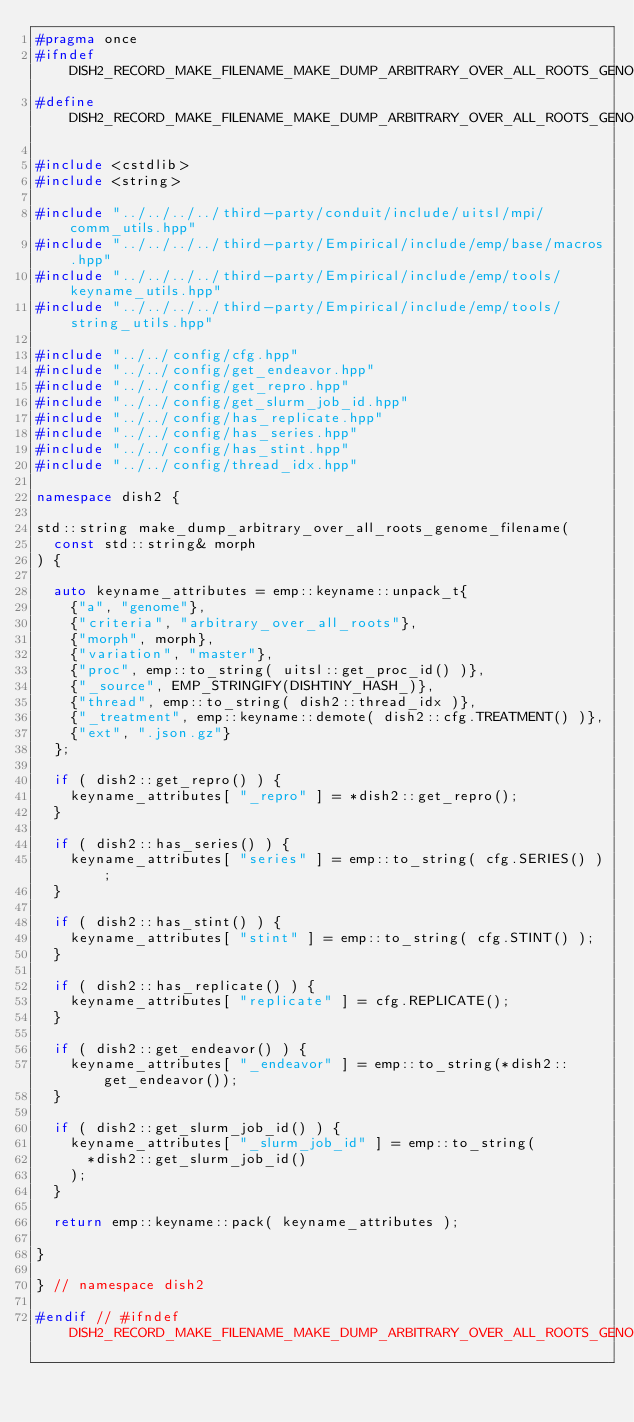<code> <loc_0><loc_0><loc_500><loc_500><_C++_>#pragma once
#ifndef DISH2_RECORD_MAKE_FILENAME_MAKE_DUMP_ARBITRARY_OVER_ALL_ROOTS_GENOME_FILENAME_HPP_INCLUDE
#define DISH2_RECORD_MAKE_FILENAME_MAKE_DUMP_ARBITRARY_OVER_ALL_ROOTS_GENOME_FILENAME_HPP_INCLUDE

#include <cstdlib>
#include <string>

#include "../../../../third-party/conduit/include/uitsl/mpi/comm_utils.hpp"
#include "../../../../third-party/Empirical/include/emp/base/macros.hpp"
#include "../../../../third-party/Empirical/include/emp/tools/keyname_utils.hpp"
#include "../../../../third-party/Empirical/include/emp/tools/string_utils.hpp"

#include "../../config/cfg.hpp"
#include "../../config/get_endeavor.hpp"
#include "../../config/get_repro.hpp"
#include "../../config/get_slurm_job_id.hpp"
#include "../../config/has_replicate.hpp"
#include "../../config/has_series.hpp"
#include "../../config/has_stint.hpp"
#include "../../config/thread_idx.hpp"

namespace dish2 {

std::string make_dump_arbitrary_over_all_roots_genome_filename(
  const std::string& morph
) {

  auto keyname_attributes = emp::keyname::unpack_t{
    {"a", "genome"},
    {"criteria", "arbitrary_over_all_roots"},
    {"morph", morph},
    {"variation", "master"},
    {"proc", emp::to_string( uitsl::get_proc_id() )},
    {"_source", EMP_STRINGIFY(DISHTINY_HASH_)},
    {"thread", emp::to_string( dish2::thread_idx )},
    {"_treatment", emp::keyname::demote( dish2::cfg.TREATMENT() )},
    {"ext", ".json.gz"}
  };

  if ( dish2::get_repro() ) {
    keyname_attributes[ "_repro" ] = *dish2::get_repro();
  }

  if ( dish2::has_series() ) {
    keyname_attributes[ "series" ] = emp::to_string( cfg.SERIES() );
  }

  if ( dish2::has_stint() ) {
    keyname_attributes[ "stint" ] = emp::to_string( cfg.STINT() );
  }

  if ( dish2::has_replicate() ) {
    keyname_attributes[ "replicate" ] = cfg.REPLICATE();
  }

  if ( dish2::get_endeavor() ) {
    keyname_attributes[ "_endeavor" ] = emp::to_string(*dish2::get_endeavor());
  }

  if ( dish2::get_slurm_job_id() ) {
    keyname_attributes[ "_slurm_job_id" ] = emp::to_string(
      *dish2::get_slurm_job_id()
    );
  }

  return emp::keyname::pack( keyname_attributes );

}

} // namespace dish2

#endif // #ifndef DISH2_RECORD_MAKE_FILENAME_MAKE_DUMP_ARBITRARY_OVER_ALL_ROOTS_GENOME_FILENAME_HPP_INCLUDE
</code> 